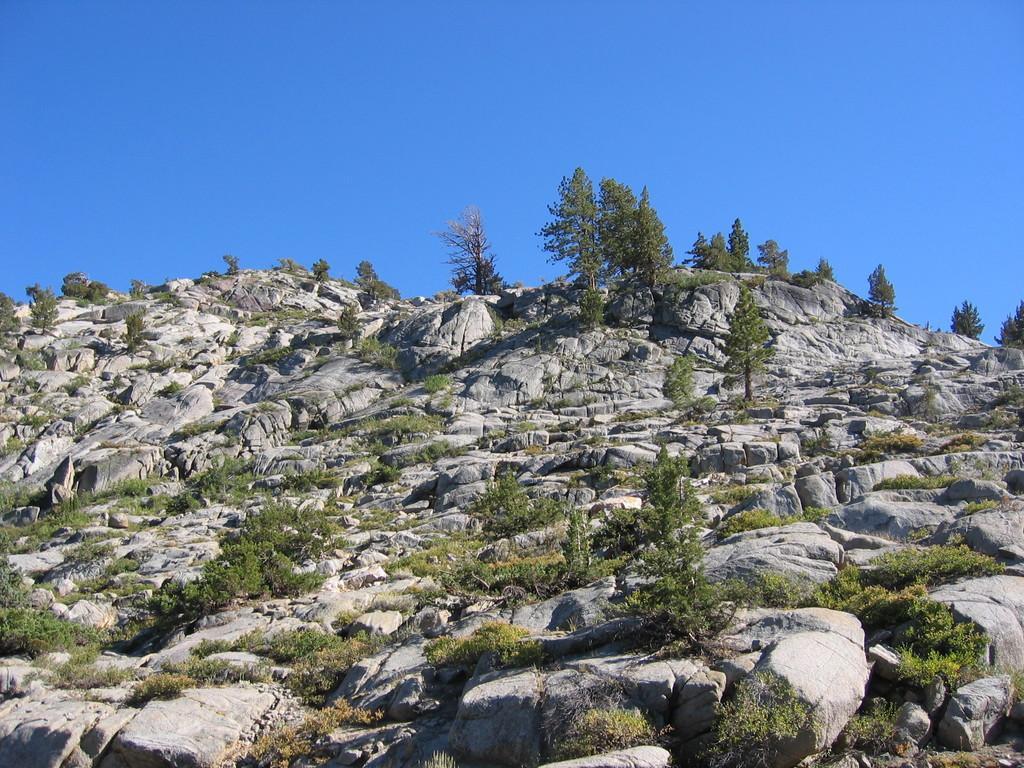Could you give a brief overview of what you see in this image? In this picture I can see there is a mountain, it has some plants, rocks, trees and the sky is clear. 